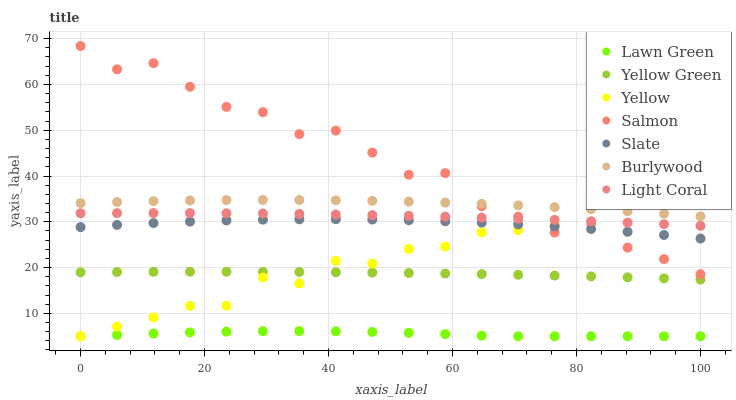Does Lawn Green have the minimum area under the curve?
Answer yes or no. Yes. Does Salmon have the maximum area under the curve?
Answer yes or no. Yes. Does Yellow Green have the minimum area under the curve?
Answer yes or no. No. Does Yellow Green have the maximum area under the curve?
Answer yes or no. No. Is Yellow Green the smoothest?
Answer yes or no. Yes. Is Salmon the roughest?
Answer yes or no. Yes. Is Burlywood the smoothest?
Answer yes or no. No. Is Burlywood the roughest?
Answer yes or no. No. Does Lawn Green have the lowest value?
Answer yes or no. Yes. Does Yellow Green have the lowest value?
Answer yes or no. No. Does Salmon have the highest value?
Answer yes or no. Yes. Does Yellow Green have the highest value?
Answer yes or no. No. Is Lawn Green less than Burlywood?
Answer yes or no. Yes. Is Burlywood greater than Light Coral?
Answer yes or no. Yes. Does Yellow intersect Salmon?
Answer yes or no. Yes. Is Yellow less than Salmon?
Answer yes or no. No. Is Yellow greater than Salmon?
Answer yes or no. No. Does Lawn Green intersect Burlywood?
Answer yes or no. No. 